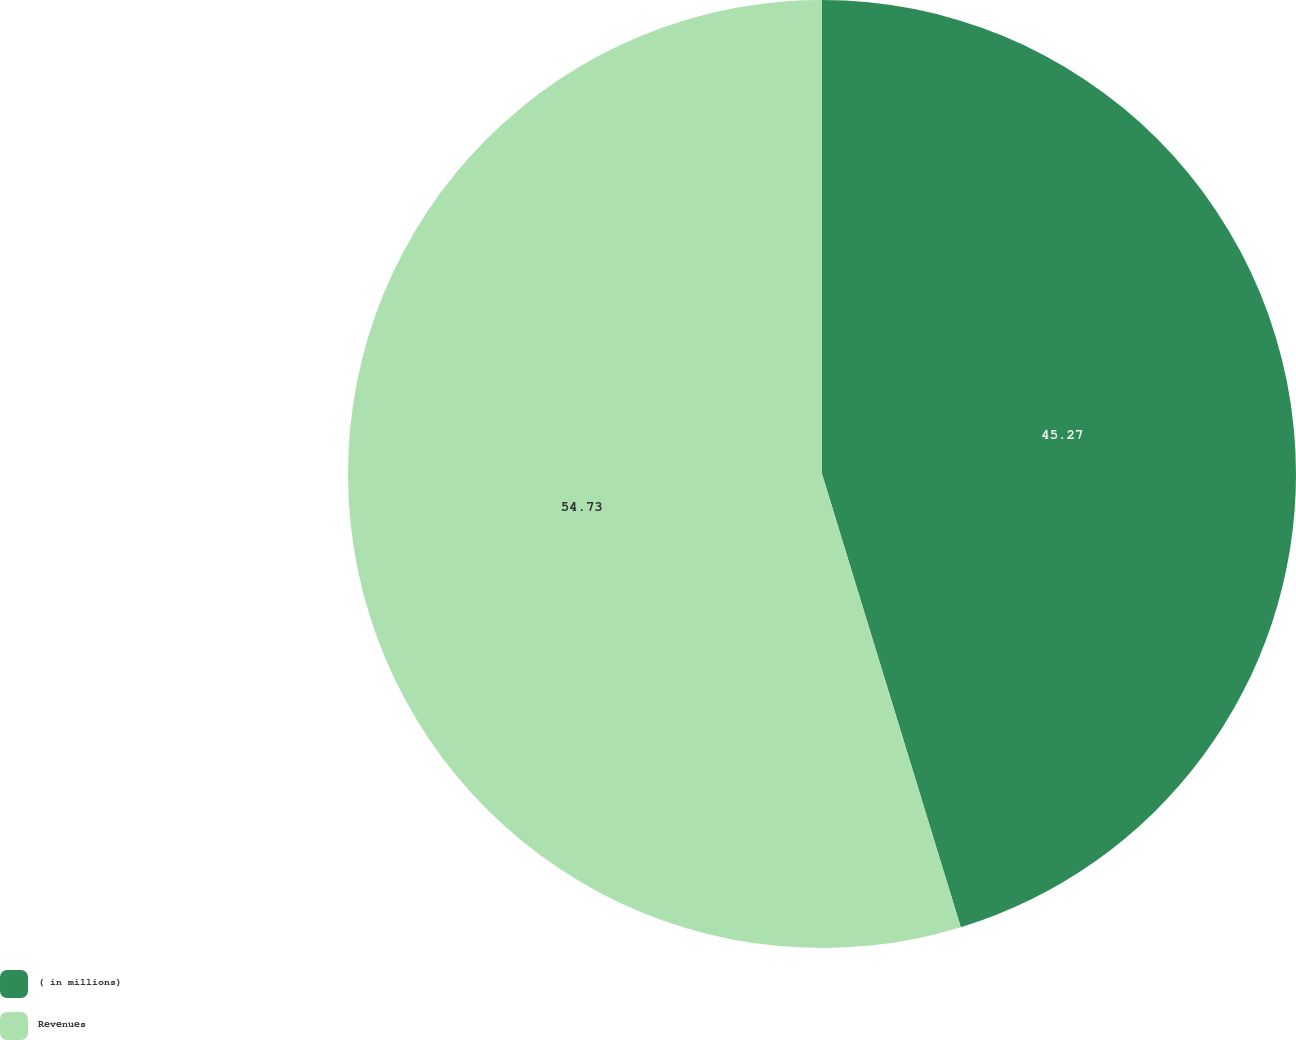Convert chart. <chart><loc_0><loc_0><loc_500><loc_500><pie_chart><fcel>( in millions)<fcel>Revenues<nl><fcel>45.27%<fcel>54.73%<nl></chart> 